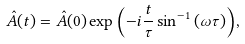Convert formula to latex. <formula><loc_0><loc_0><loc_500><loc_500>\hat { A } ( t ) = \hat { A } ( 0 ) \exp { \left ( { - i \frac { t } { \tau } \sin ^ { - 1 } { ( \omega \tau ) } } \right ) } ,</formula> 